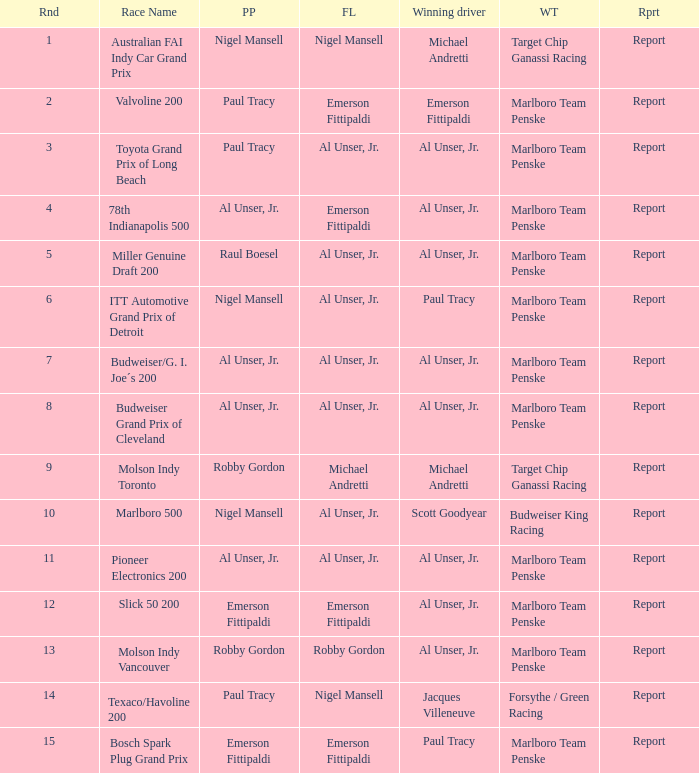Who was at the pole position in the ITT Automotive Grand Prix of Detroit, won by Paul Tracy? Nigel Mansell. 